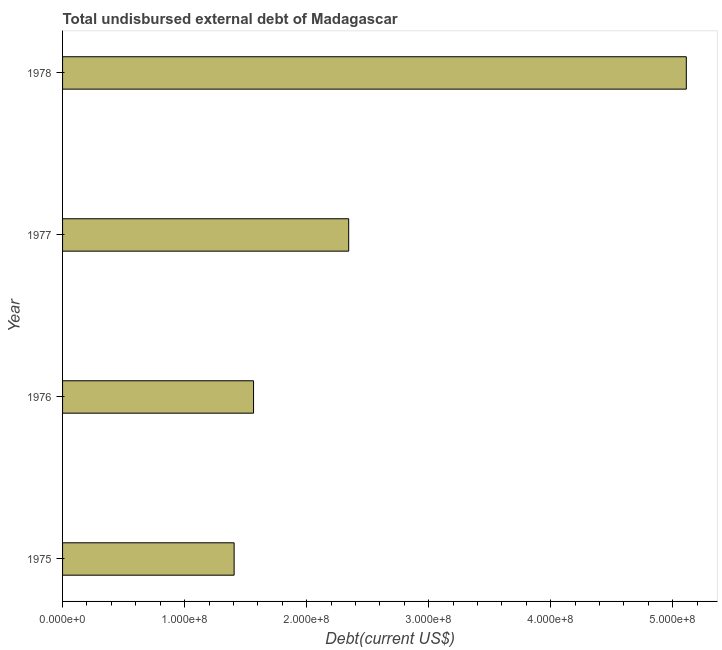Does the graph contain any zero values?
Your response must be concise. No. Does the graph contain grids?
Keep it short and to the point. No. What is the title of the graph?
Your answer should be compact. Total undisbursed external debt of Madagascar. What is the label or title of the X-axis?
Offer a very short reply. Debt(current US$). What is the total debt in 1976?
Provide a short and direct response. 1.56e+08. Across all years, what is the maximum total debt?
Give a very brief answer. 5.11e+08. Across all years, what is the minimum total debt?
Give a very brief answer. 1.41e+08. In which year was the total debt maximum?
Give a very brief answer. 1978. In which year was the total debt minimum?
Your answer should be compact. 1975. What is the sum of the total debt?
Your answer should be compact. 1.04e+09. What is the difference between the total debt in 1976 and 1977?
Keep it short and to the point. -7.79e+07. What is the average total debt per year?
Provide a succinct answer. 2.61e+08. What is the median total debt?
Keep it short and to the point. 1.95e+08. Is the total debt in 1975 less than that in 1976?
Ensure brevity in your answer.  Yes. Is the difference between the total debt in 1977 and 1978 greater than the difference between any two years?
Offer a very short reply. No. What is the difference between the highest and the second highest total debt?
Keep it short and to the point. 2.77e+08. What is the difference between the highest and the lowest total debt?
Offer a terse response. 3.71e+08. Are the values on the major ticks of X-axis written in scientific E-notation?
Ensure brevity in your answer.  Yes. What is the Debt(current US$) in 1975?
Ensure brevity in your answer.  1.41e+08. What is the Debt(current US$) in 1976?
Your response must be concise. 1.56e+08. What is the Debt(current US$) of 1977?
Provide a succinct answer. 2.34e+08. What is the Debt(current US$) in 1978?
Offer a very short reply. 5.11e+08. What is the difference between the Debt(current US$) in 1975 and 1976?
Provide a short and direct response. -1.59e+07. What is the difference between the Debt(current US$) in 1975 and 1977?
Provide a short and direct response. -9.39e+07. What is the difference between the Debt(current US$) in 1975 and 1978?
Your answer should be compact. -3.71e+08. What is the difference between the Debt(current US$) in 1976 and 1977?
Give a very brief answer. -7.79e+07. What is the difference between the Debt(current US$) in 1976 and 1978?
Offer a very short reply. -3.55e+08. What is the difference between the Debt(current US$) in 1977 and 1978?
Your answer should be very brief. -2.77e+08. What is the ratio of the Debt(current US$) in 1975 to that in 1976?
Offer a terse response. 0.9. What is the ratio of the Debt(current US$) in 1975 to that in 1977?
Your answer should be compact. 0.6. What is the ratio of the Debt(current US$) in 1975 to that in 1978?
Your response must be concise. 0.28. What is the ratio of the Debt(current US$) in 1976 to that in 1977?
Ensure brevity in your answer.  0.67. What is the ratio of the Debt(current US$) in 1976 to that in 1978?
Give a very brief answer. 0.31. What is the ratio of the Debt(current US$) in 1977 to that in 1978?
Give a very brief answer. 0.46. 